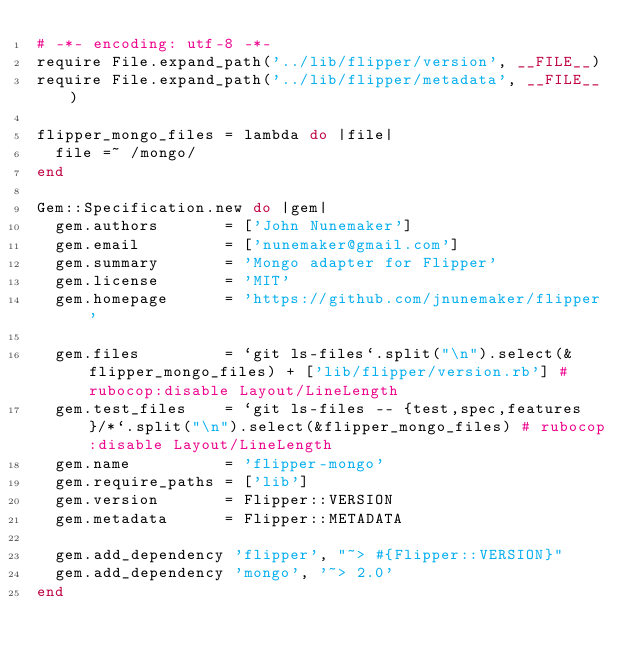Convert code to text. <code><loc_0><loc_0><loc_500><loc_500><_Ruby_># -*- encoding: utf-8 -*-
require File.expand_path('../lib/flipper/version', __FILE__)
require File.expand_path('../lib/flipper/metadata', __FILE__)

flipper_mongo_files = lambda do |file|
  file =~ /mongo/
end

Gem::Specification.new do |gem|
  gem.authors       = ['John Nunemaker']
  gem.email         = ['nunemaker@gmail.com']
  gem.summary       = 'Mongo adapter for Flipper'
  gem.license       = 'MIT'
  gem.homepage      = 'https://github.com/jnunemaker/flipper'

  gem.files         = `git ls-files`.split("\n").select(&flipper_mongo_files) + ['lib/flipper/version.rb'] # rubocop:disable Layout/LineLength
  gem.test_files    = `git ls-files -- {test,spec,features}/*`.split("\n").select(&flipper_mongo_files) # rubocop:disable Layout/LineLength
  gem.name          = 'flipper-mongo'
  gem.require_paths = ['lib']
  gem.version       = Flipper::VERSION
  gem.metadata      = Flipper::METADATA

  gem.add_dependency 'flipper', "~> #{Flipper::VERSION}"
  gem.add_dependency 'mongo', '~> 2.0'
end
</code> 